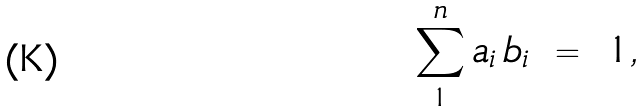Convert formula to latex. <formula><loc_0><loc_0><loc_500><loc_500>\sum _ { 1 } ^ { n } a _ { i } \, b _ { i } \ = \ 1 ,</formula> 